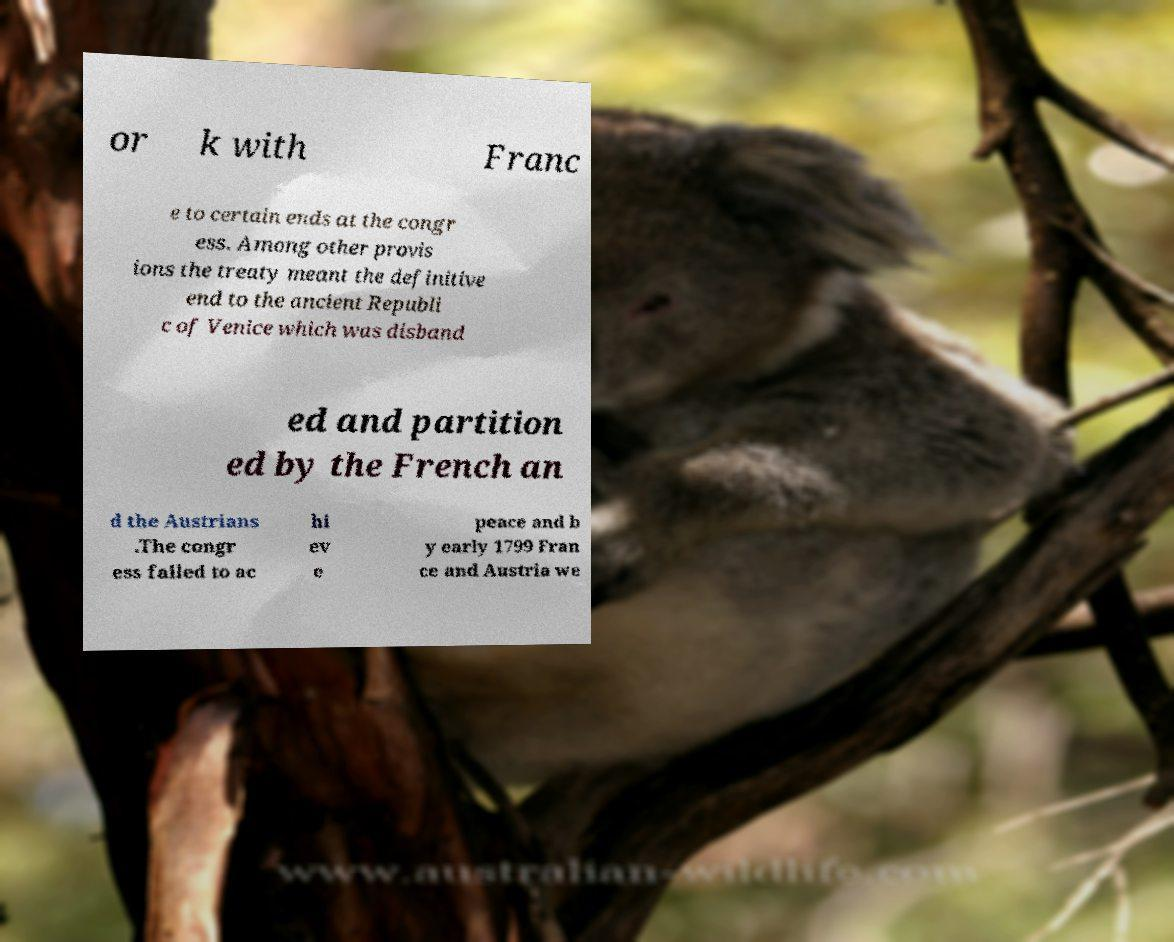Could you extract and type out the text from this image? or k with Franc e to certain ends at the congr ess. Among other provis ions the treaty meant the definitive end to the ancient Republi c of Venice which was disband ed and partition ed by the French an d the Austrians .The congr ess failed to ac hi ev e peace and b y early 1799 Fran ce and Austria we 